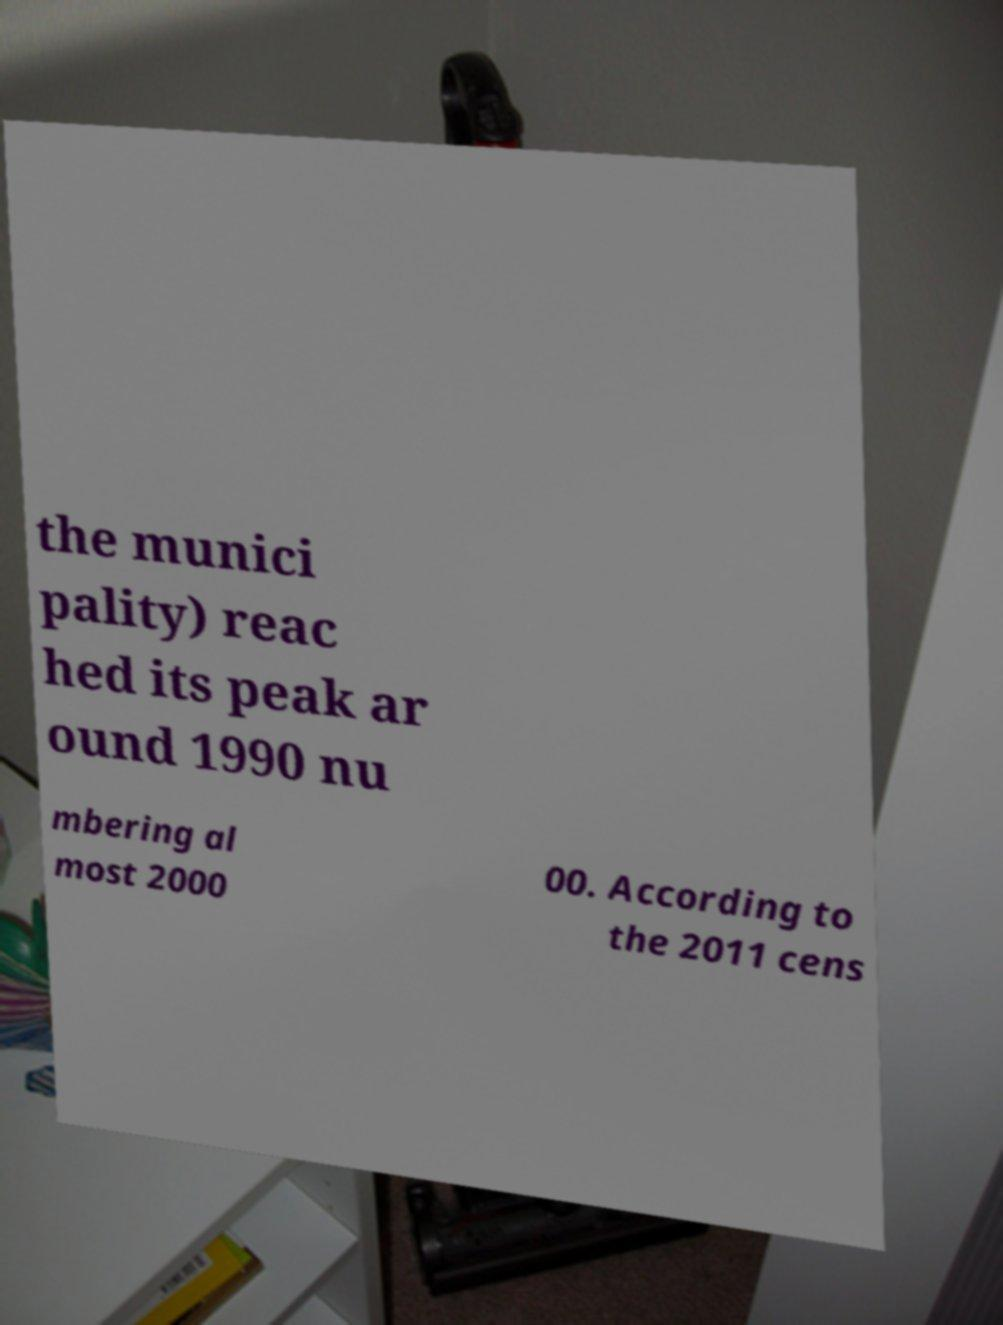Could you extract and type out the text from this image? the munici pality) reac hed its peak ar ound 1990 nu mbering al most 2000 00. According to the 2011 cens 